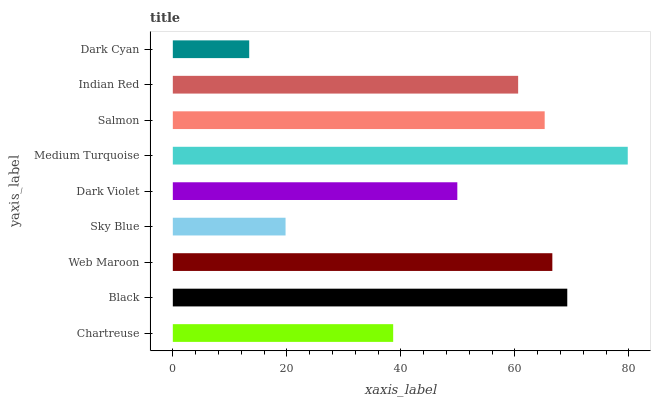Is Dark Cyan the minimum?
Answer yes or no. Yes. Is Medium Turquoise the maximum?
Answer yes or no. Yes. Is Black the minimum?
Answer yes or no. No. Is Black the maximum?
Answer yes or no. No. Is Black greater than Chartreuse?
Answer yes or no. Yes. Is Chartreuse less than Black?
Answer yes or no. Yes. Is Chartreuse greater than Black?
Answer yes or no. No. Is Black less than Chartreuse?
Answer yes or no. No. Is Indian Red the high median?
Answer yes or no. Yes. Is Indian Red the low median?
Answer yes or no. Yes. Is Dark Cyan the high median?
Answer yes or no. No. Is Sky Blue the low median?
Answer yes or no. No. 